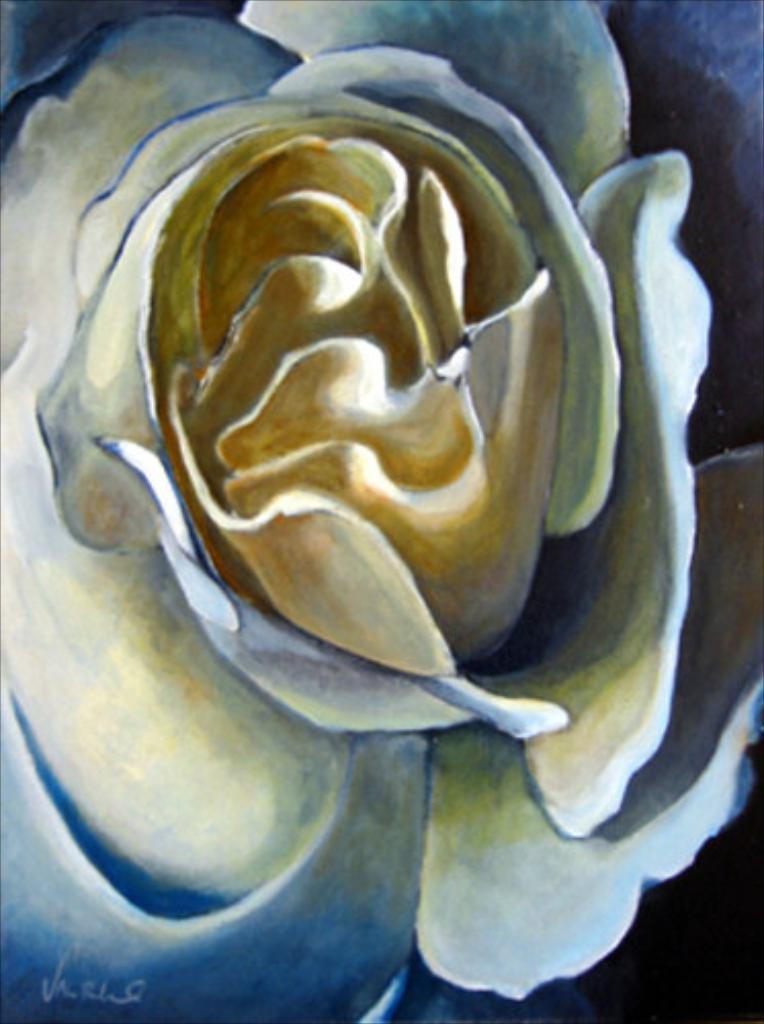What is the main subject of the painting in the image? The main subject of the painting in the image is a flower. Where is the painting located in the image? The painting is in the center of the image. What else can be seen at the bottom of the image? There is text at the bottom of the image. How many mice are running around the flower in the painting? There are no mice present in the image, as the painting features a flower and not any animals. 